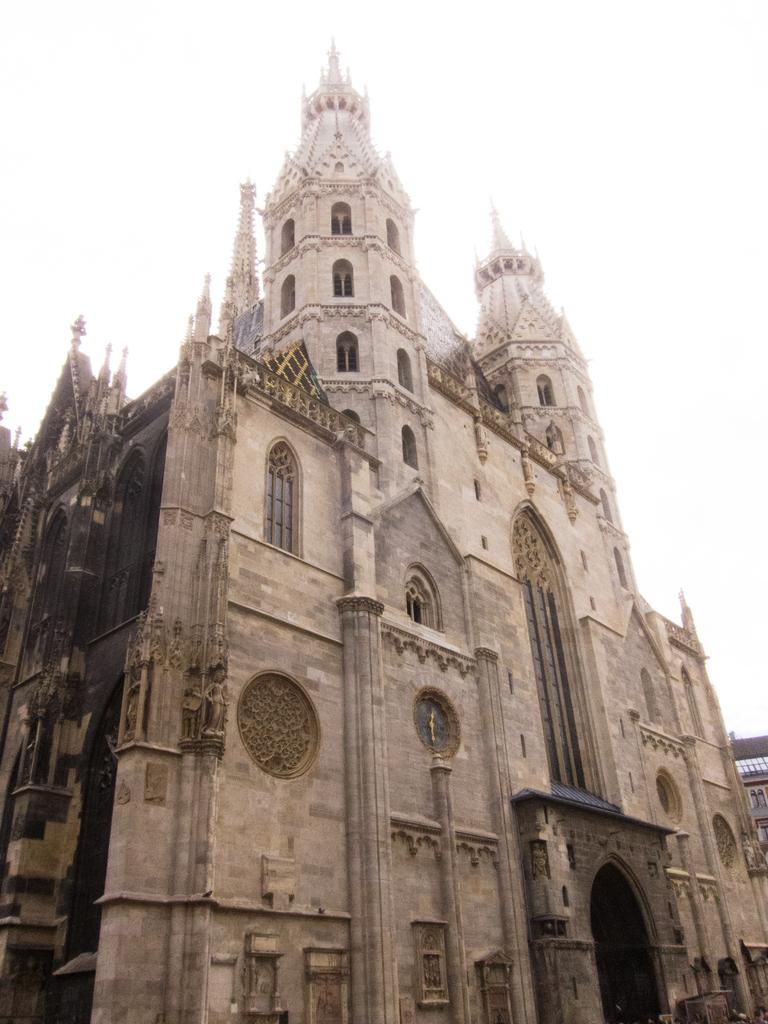What type of structure is the main subject of the image? There is a castle in the image. Can you describe the castle's appearance? The castle appears to have towers, walls, and possibly a drawbridge or gate. What might be the historical or cultural significance of the castle? The castle's significance would depend on its location and history, which is not mentioned in the provided facts. What type of grape is being sold at the store in the image? There is no store or grape present in the image; it features a castle. 